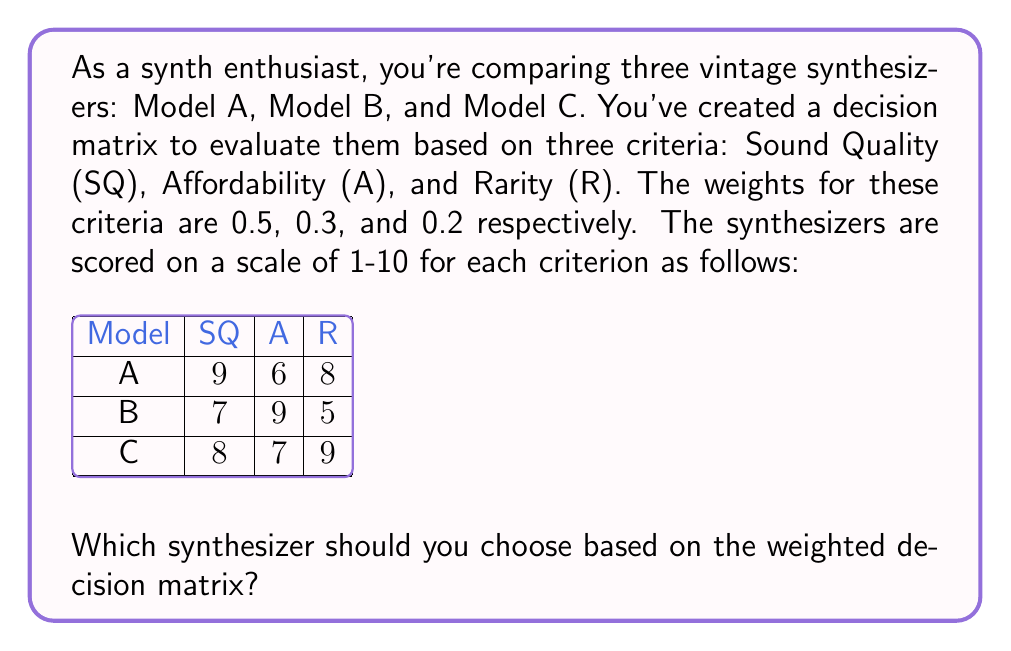Solve this math problem. To solve this problem, we need to calculate the weighted score for each synthesizer and choose the one with the highest score. Let's go through this step-by-step:

1) First, recall the weights for each criterion:
   Sound Quality (SQ): 0.5
   Affordability (A): 0.3
   Rarity (R): 0.2

2) Now, let's calculate the weighted score for each synthesizer:

   For Model A:
   $$(9 \times 0.5) + (6 \times 0.3) + (8 \times 0.2) = 4.5 + 1.8 + 1.6 = 7.9$$

   For Model B:
   $$(7 \times 0.5) + (9 \times 0.3) + (5 \times 0.2) = 3.5 + 2.7 + 1.0 = 7.2$$

   For Model C:
   $$(8 \times 0.5) + (7 \times 0.3) + (9 \times 0.2) = 4.0 + 2.1 + 1.8 = 7.9$$

3) Comparing the final scores:
   Model A: 7.9
   Model B: 7.2
   Model C: 7.9

4) We can see that Models A and C have the highest score of 7.9, while Model B has a lower score of 7.2.

Therefore, based on this weighted decision matrix, you should choose either Model A or Model C, as they have the highest overall scores.
Answer: Model A or Model C 